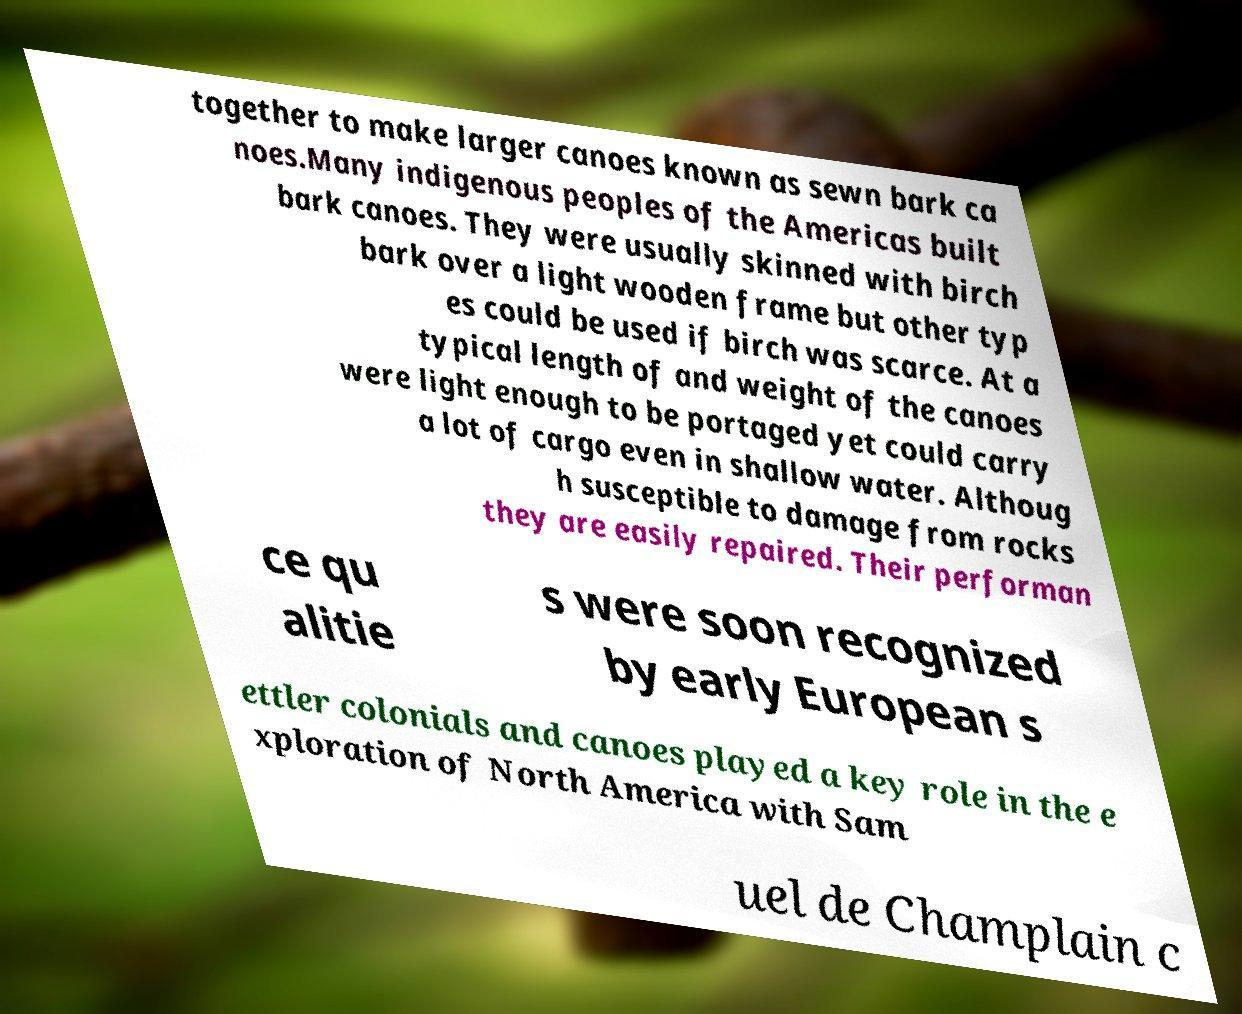There's text embedded in this image that I need extracted. Can you transcribe it verbatim? together to make larger canoes known as sewn bark ca noes.Many indigenous peoples of the Americas built bark canoes. They were usually skinned with birch bark over a light wooden frame but other typ es could be used if birch was scarce. At a typical length of and weight of the canoes were light enough to be portaged yet could carry a lot of cargo even in shallow water. Althoug h susceptible to damage from rocks they are easily repaired. Their performan ce qu alitie s were soon recognized by early European s ettler colonials and canoes played a key role in the e xploration of North America with Sam uel de Champlain c 